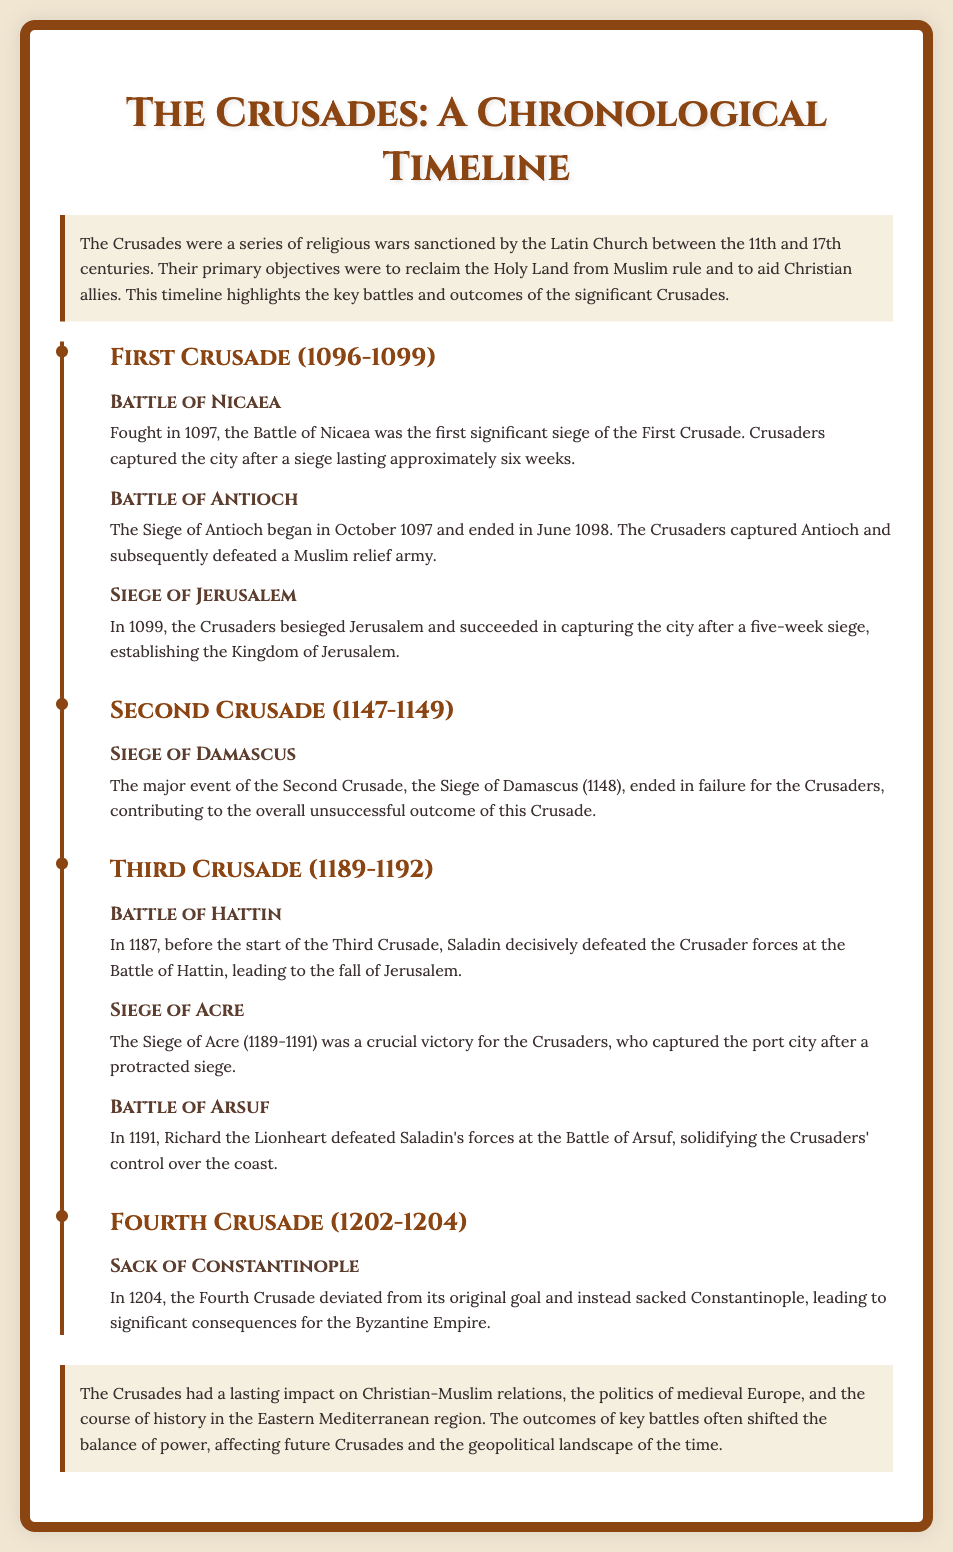What year did the First Crusade begin? The First Crusade began in 1096, as stated in the timeline.
Answer: 1096 Which battle marked the end of the Siege of Antioch? The Siege of Antioch ended in June 1098 when the Crusaders captured the city.
Answer: June 1098 What was a major outcome of the Second Crusade? The major event of the Second Crusade, the Siege of Damascus, ended in failure for the Crusaders.
Answer: Failure Who was defeated at the Battle of Hattin? Saladin decisively defeated the Crusader forces at the Battle of Hattin.
Answer: Crusader forces What event occurred during the Fourth Crusade in 1204? In 1204, the Fourth Crusade deviated from its original goal and sacked Constantinople.
Answer: Sack of Constantinople How long did the Siege of Jerusalem last? The Siege of Jerusalem lasted five weeks, leading to the capture of the city by the Crusaders.
Answer: Five weeks What is a key impact of the Crusades mentioned in the document? The Crusades had a lasting impact on Christian-Muslim relations, as stated in the conclusion.
Answer: Christian-Muslim relations What crucial victory did Crusaders achieve during the Third Crusade? The Siege of Acre was a crucial victory for the Crusaders during the Third Crusade.
Answer: Siege of Acre What theme does the introduction of the slide highlight? The introduction highlights that the Crusades were sanctioned by the Latin Church with objectives to reclaim the Holy Land.
Answer: Sanctioned by the Latin Church 